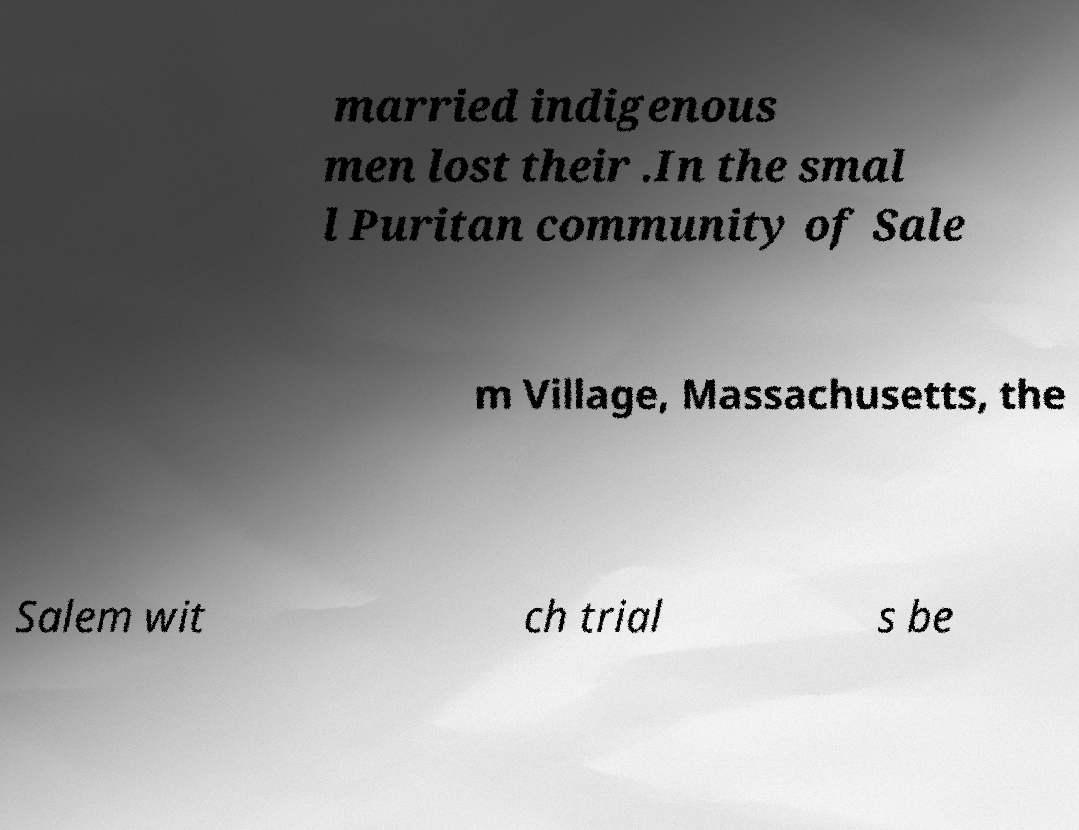Could you assist in decoding the text presented in this image and type it out clearly? married indigenous men lost their .In the smal l Puritan community of Sale m Village, Massachusetts, the Salem wit ch trial s be 